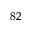Convert formula to latex. <formula><loc_0><loc_0><loc_500><loc_500>^ { 8 2 }</formula> 